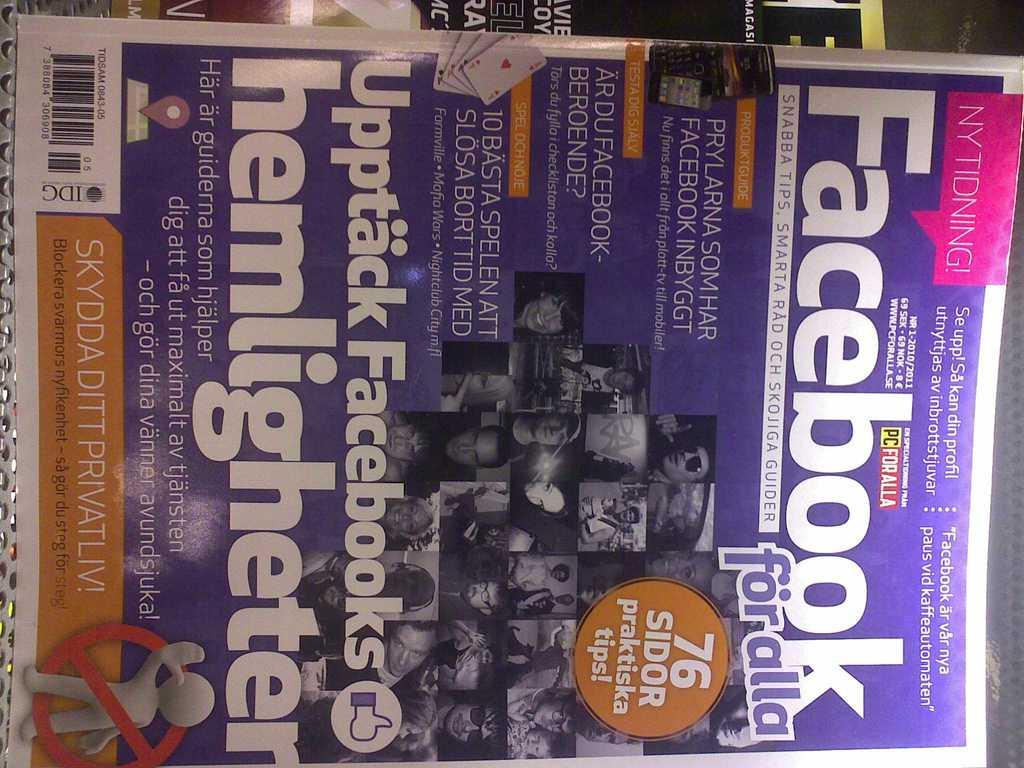What is the name of the magazine?
Your answer should be compact. Facebook. 